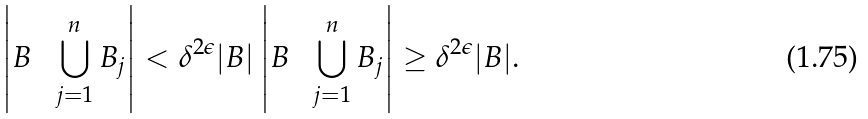<formula> <loc_0><loc_0><loc_500><loc_500>\left | B \, \ \, \bigcup _ { j = 1 } ^ { n } B _ { j } \right | < \delta ^ { 2 \epsilon } | B | \left | B \, \ \, \bigcup _ { j = 1 } ^ { n } B _ { j } \right | \geq \delta ^ { 2 \epsilon } | B | .</formula> 